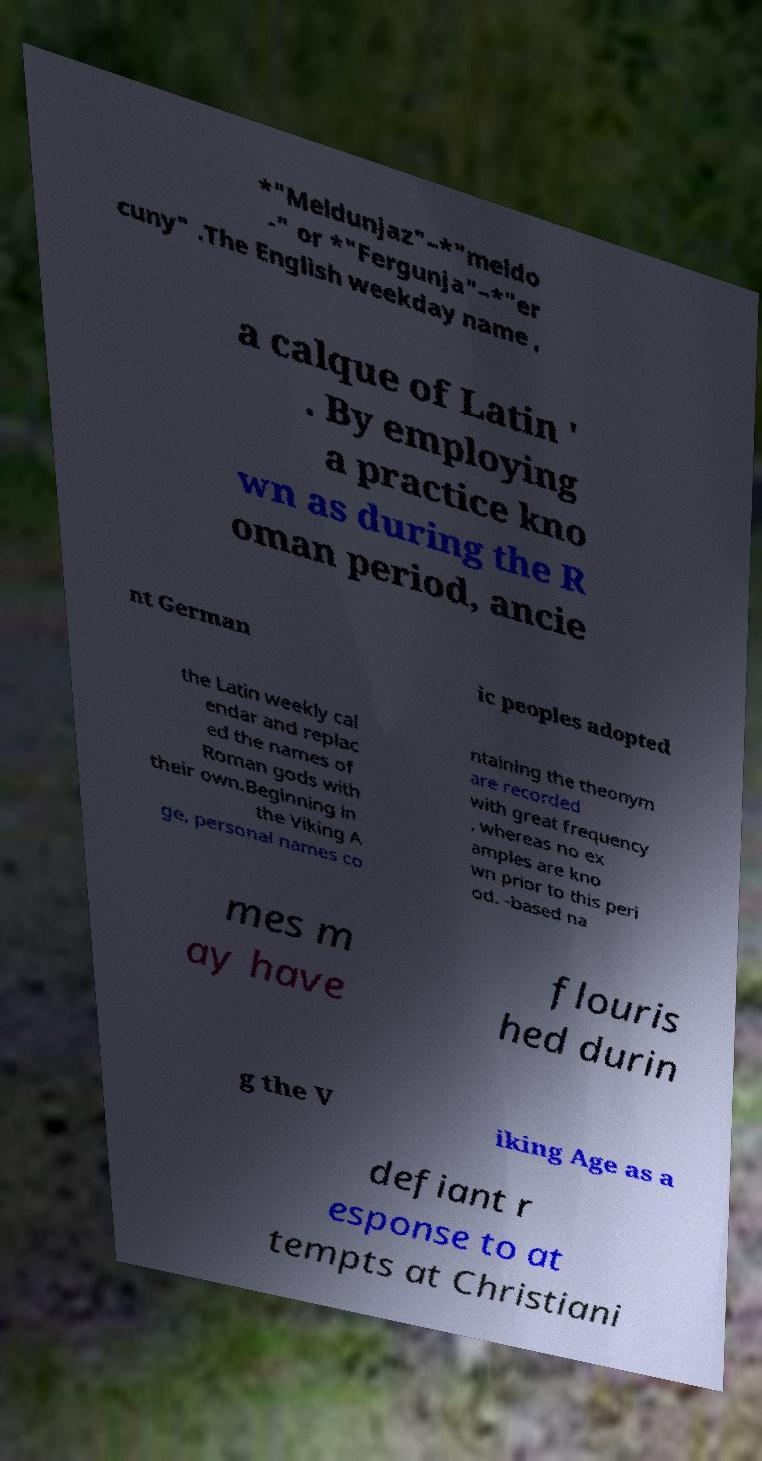Can you read and provide the text displayed in the image?This photo seems to have some interesting text. Can you extract and type it out for me? *"Meldunjaz"–*"meldo -" or *"Fergunja"–*"er cuny" .The English weekday name , a calque of Latin ' . By employing a practice kno wn as during the R oman period, ancie nt German ic peoples adopted the Latin weekly cal endar and replac ed the names of Roman gods with their own.Beginning in the Viking A ge, personal names co ntaining the theonym are recorded with great frequency , whereas no ex amples are kno wn prior to this peri od. -based na mes m ay have flouris hed durin g the V iking Age as a defiant r esponse to at tempts at Christiani 